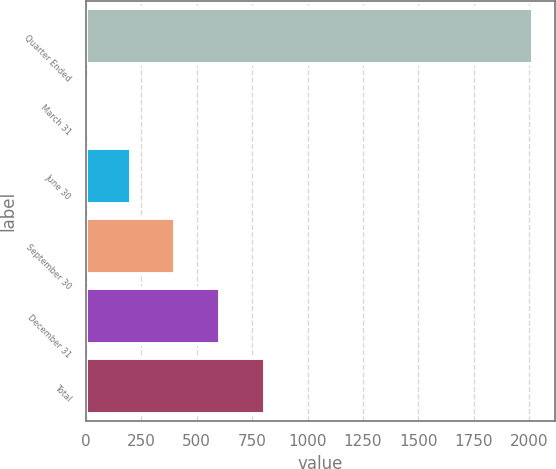Convert chart. <chart><loc_0><loc_0><loc_500><loc_500><bar_chart><fcel>Quarter Ended<fcel>March 31<fcel>June 30<fcel>September 30<fcel>December 31<fcel>Total<nl><fcel>2017<fcel>0.39<fcel>202.05<fcel>403.71<fcel>605.37<fcel>807.03<nl></chart> 